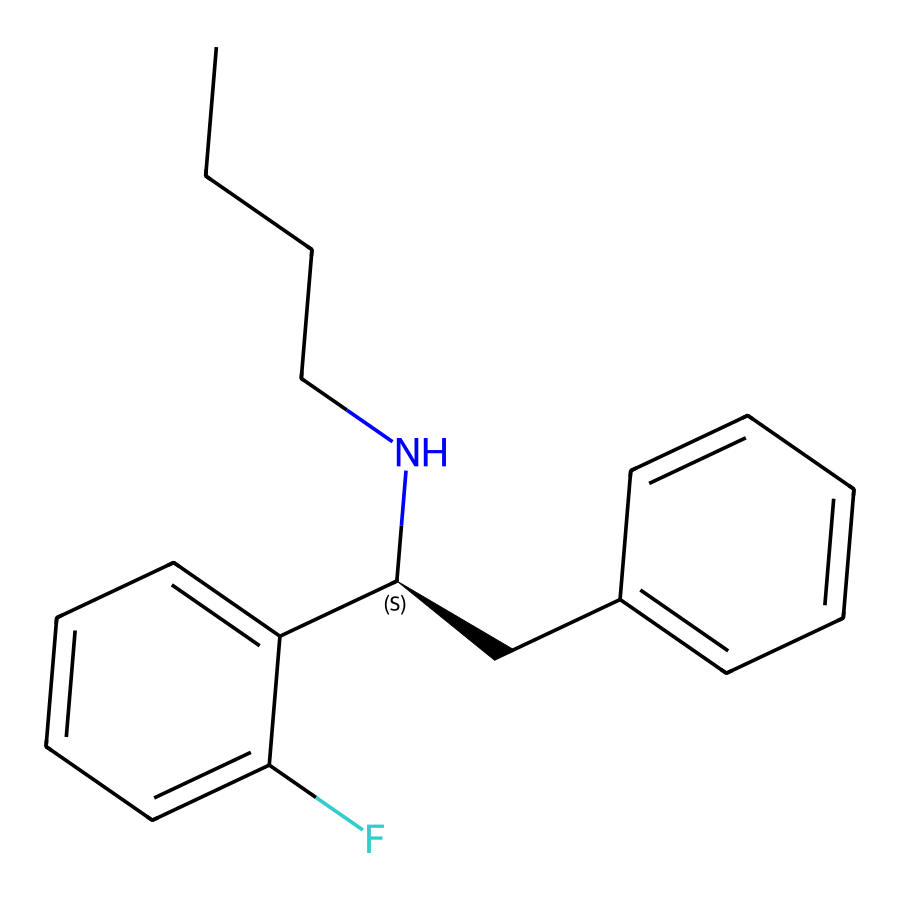How many carbon atoms are present in this chemical? Counting the 'C' symbols in the SMILES representation reveals a total of 14 carbon atoms in the structure of fluoxetine.
Answer: 14 What is the functional group present in fluoxetine? The structure contains an amine group, indicated by the nitrogen atom (N) bonded to carbon chains, which is characteristic of antidepressants.
Answer: amine Identify the molecular formula of fluoxetine. By converting the SMILES representation and counting the atoms, the molecular formula is determined to be C17H18F2N.
Answer: C17H18F2N What is the primary use of fluoxetine in medicine? Fluoxetine is primarily used as an antidepressant that treats conditions like major depressive disorder and anxiety disorders.
Answer: antidepressant Which part of the chemical structure is characteristic of its antidepressant properties? The presence of the trifluoromethyl group (the fluorine atoms) in fluoxetine contributes to its effectiveness as a selective serotonin reuptake inhibitor (SSRI).
Answer: trifluoromethyl group How is fluoxetine typically administered? Fluoxetine is usually taken orally in capsule or tablet form, aligning with common drug administration routes.
Answer: orally What type of drug is fluoxetine categorized as? Fluoxetine is categorized specifically as a selective serotonin reuptake inhibitor (SSRI), based on its chemical interactions and application in mood regulation.
Answer: SSRI 